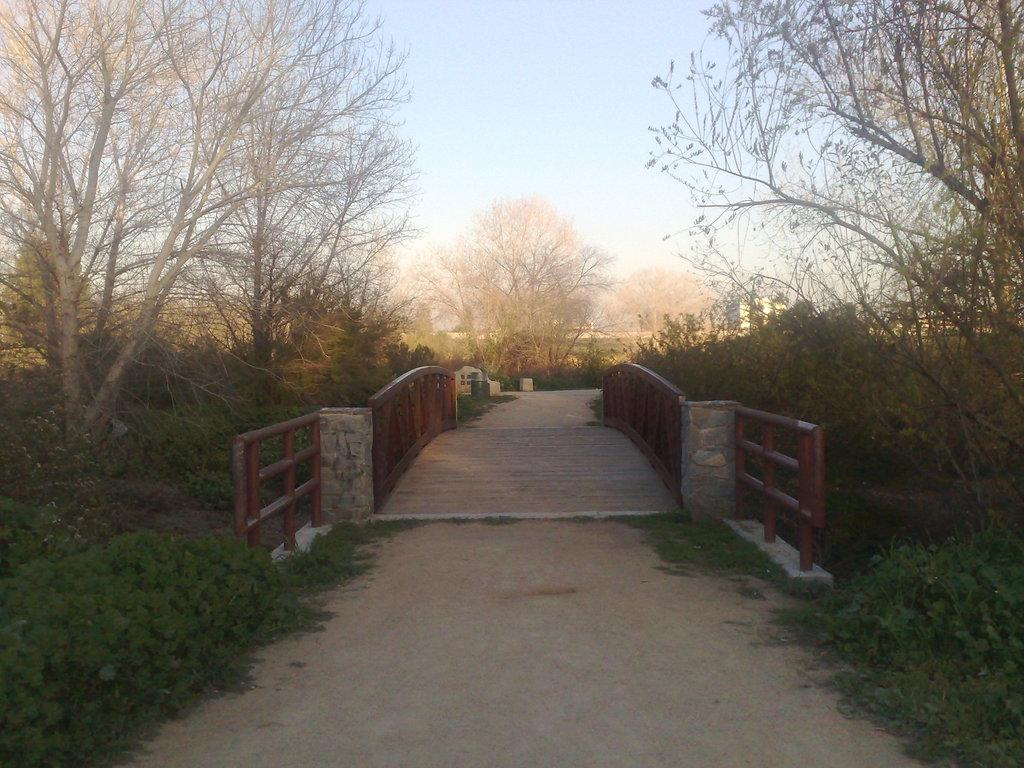What type of bridge is depicted in the image? There is a single lane bridge in the image. How wide is the bridge? The bridge is narrow. What can be seen in the background of the image? The bridge is surrounded by trees. Are there any plants near the bridge? Yes, there are plants in the vicinity of the bridge. Who is the lead servant in the image? There are no people, let alone servants, present in the image. The image features a single lane bridge surrounded by trees and plants. 